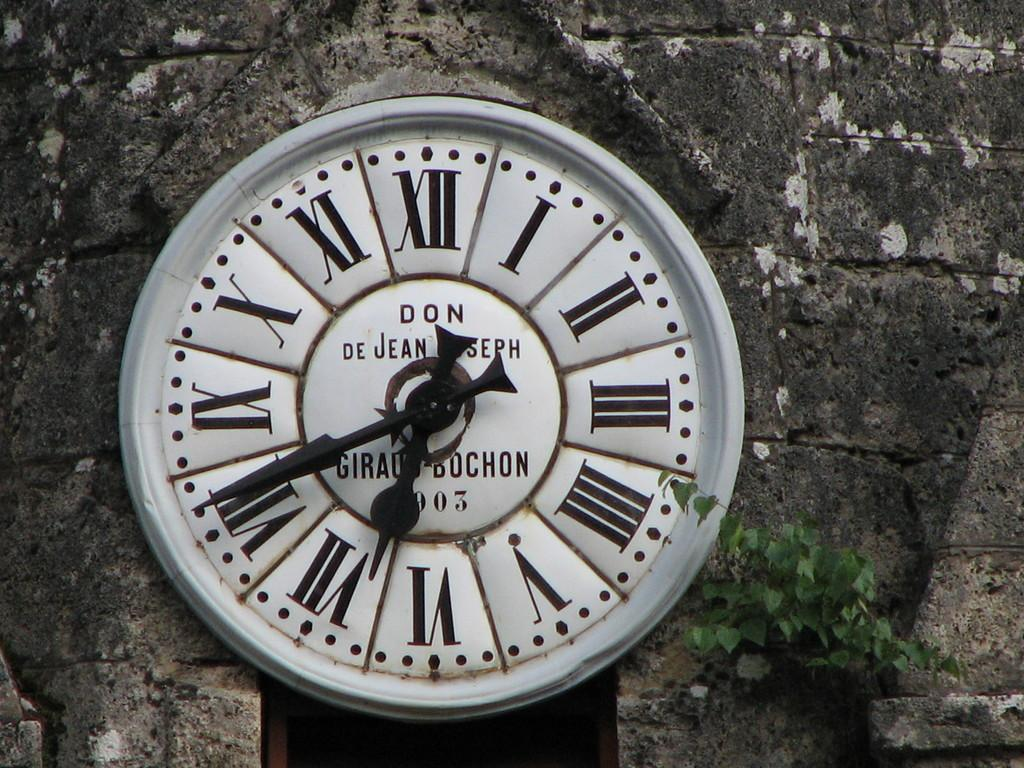<image>
Create a compact narrative representing the image presented. an old clock with ethe words Don de Jean is sitting in front of an old stone wall 